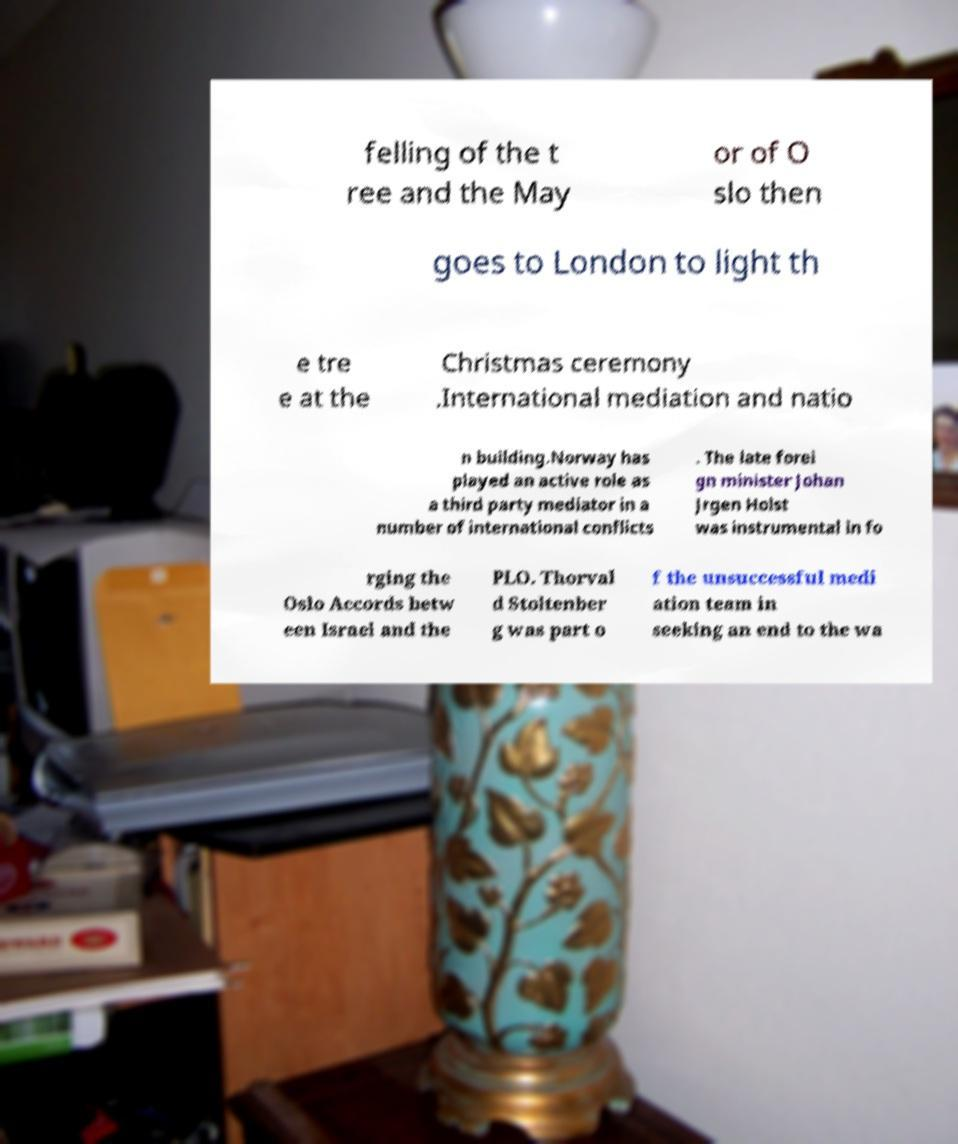Could you assist in decoding the text presented in this image and type it out clearly? felling of the t ree and the May or of O slo then goes to London to light th e tre e at the Christmas ceremony .International mediation and natio n building.Norway has played an active role as a third party mediator in a number of international conflicts . The late forei gn minister Johan Jrgen Holst was instrumental in fo rging the Oslo Accords betw een Israel and the PLO. Thorval d Stoltenber g was part o f the unsuccessful medi ation team in seeking an end to the wa 